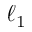<formula> <loc_0><loc_0><loc_500><loc_500>\ell _ { 1 }</formula> 